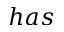Convert formula to latex. <formula><loc_0><loc_0><loc_500><loc_500>h a s</formula> 